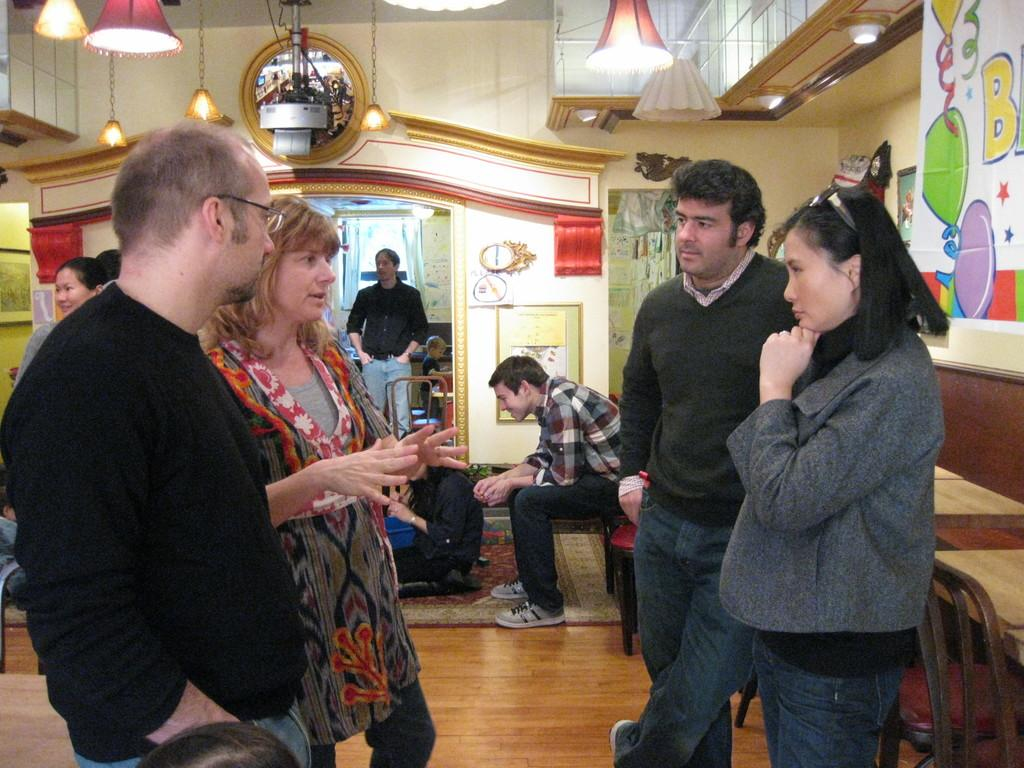How many people are in the image? There are multiple people in the image. What are some of the people doing in the image? Some people are talking to each other, while others are sitting or standing. Can you see a goat playing a guitar in the image? No, there is no goat or guitar present in the image. 